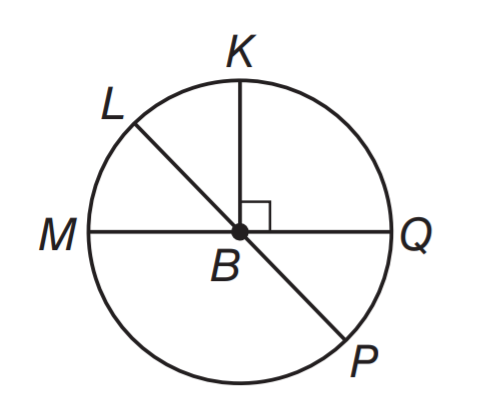Answer the mathemtical geometry problem and directly provide the correct option letter.
Question: What is the area of the shaded region if r = 4.
Choices: A: 16 - 16 \pi B: 16 - 8 \pi C: 64 - 16 \pi D: 64 - 8 \pi C 